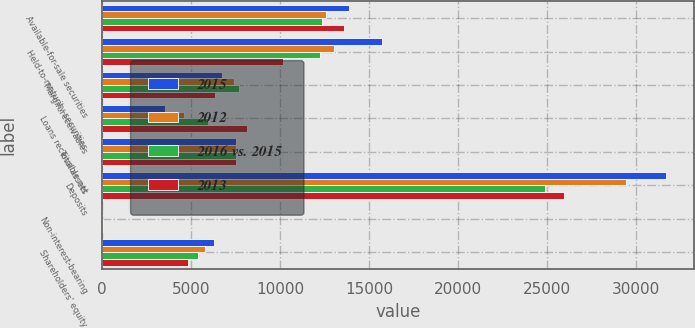Convert chart to OTSL. <chart><loc_0><loc_0><loc_500><loc_500><stacked_bar_chart><ecel><fcel>Available-for-sale securities<fcel>Held-to-maturity securities<fcel>Margin receivables<fcel>Loans receivable net<fcel>Total assets<fcel>Deposits<fcel>Non-interest-bearing<fcel>Shareholders' equity<nl><fcel>2015<fcel>13892<fcel>15751<fcel>6731<fcel>3551<fcel>7536.5<fcel>31682<fcel>3<fcel>6272<nl><fcel>2012<fcel>12589<fcel>13013<fcel>7398<fcel>4613<fcel>7536.5<fcel>29445<fcel>8<fcel>5799<nl><fcel>2016 vs. 2015<fcel>12388<fcel>12248<fcel>7675<fcel>5979<fcel>7536.5<fcel>24890<fcel>38<fcel>5375<nl><fcel>2013<fcel>13592<fcel>10181<fcel>6353<fcel>8123<fcel>7536.5<fcel>25971<fcel>42<fcel>4856<nl></chart> 